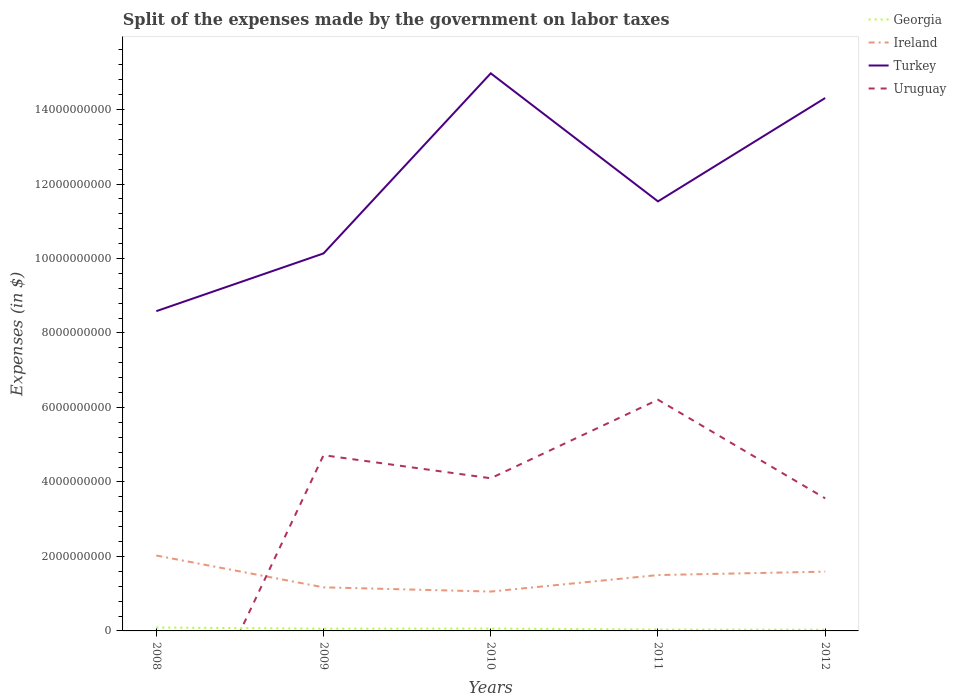How many different coloured lines are there?
Provide a short and direct response. 4. Does the line corresponding to Uruguay intersect with the line corresponding to Ireland?
Offer a terse response. Yes. Across all years, what is the maximum expenses made by the government on labor taxes in Ireland?
Offer a terse response. 1.06e+09. What is the total expenses made by the government on labor taxes in Turkey in the graph?
Make the answer very short. -4.84e+09. What is the difference between the highest and the second highest expenses made by the government on labor taxes in Uruguay?
Ensure brevity in your answer.  6.21e+09. What is the difference between the highest and the lowest expenses made by the government on labor taxes in Ireland?
Give a very brief answer. 3. Is the expenses made by the government on labor taxes in Turkey strictly greater than the expenses made by the government on labor taxes in Ireland over the years?
Provide a succinct answer. No. How many lines are there?
Your response must be concise. 4. What is the difference between two consecutive major ticks on the Y-axis?
Keep it short and to the point. 2.00e+09. Are the values on the major ticks of Y-axis written in scientific E-notation?
Your response must be concise. No. Does the graph contain any zero values?
Your answer should be very brief. Yes. Does the graph contain grids?
Offer a terse response. No. How many legend labels are there?
Keep it short and to the point. 4. How are the legend labels stacked?
Ensure brevity in your answer.  Vertical. What is the title of the graph?
Ensure brevity in your answer.  Split of the expenses made by the government on labor taxes. What is the label or title of the Y-axis?
Provide a short and direct response. Expenses (in $). What is the Expenses (in $) of Georgia in 2008?
Offer a very short reply. 9.18e+07. What is the Expenses (in $) in Ireland in 2008?
Keep it short and to the point. 2.02e+09. What is the Expenses (in $) in Turkey in 2008?
Make the answer very short. 8.59e+09. What is the Expenses (in $) of Uruguay in 2008?
Provide a succinct answer. 0. What is the Expenses (in $) of Georgia in 2009?
Offer a very short reply. 6.00e+07. What is the Expenses (in $) in Ireland in 2009?
Provide a succinct answer. 1.17e+09. What is the Expenses (in $) in Turkey in 2009?
Provide a short and direct response. 1.01e+1. What is the Expenses (in $) in Uruguay in 2009?
Provide a succinct answer. 4.72e+09. What is the Expenses (in $) of Georgia in 2010?
Ensure brevity in your answer.  6.31e+07. What is the Expenses (in $) in Ireland in 2010?
Offer a very short reply. 1.06e+09. What is the Expenses (in $) of Turkey in 2010?
Offer a very short reply. 1.50e+1. What is the Expenses (in $) in Uruguay in 2010?
Provide a succinct answer. 4.10e+09. What is the Expenses (in $) in Georgia in 2011?
Offer a terse response. 3.76e+07. What is the Expenses (in $) in Ireland in 2011?
Ensure brevity in your answer.  1.50e+09. What is the Expenses (in $) of Turkey in 2011?
Your response must be concise. 1.15e+1. What is the Expenses (in $) of Uruguay in 2011?
Your response must be concise. 6.21e+09. What is the Expenses (in $) in Georgia in 2012?
Provide a succinct answer. 3.37e+07. What is the Expenses (in $) in Ireland in 2012?
Offer a terse response. 1.59e+09. What is the Expenses (in $) of Turkey in 2012?
Offer a very short reply. 1.43e+1. What is the Expenses (in $) in Uruguay in 2012?
Your answer should be compact. 3.56e+09. Across all years, what is the maximum Expenses (in $) in Georgia?
Make the answer very short. 9.18e+07. Across all years, what is the maximum Expenses (in $) of Ireland?
Your answer should be compact. 2.02e+09. Across all years, what is the maximum Expenses (in $) of Turkey?
Provide a short and direct response. 1.50e+1. Across all years, what is the maximum Expenses (in $) of Uruguay?
Provide a succinct answer. 6.21e+09. Across all years, what is the minimum Expenses (in $) of Georgia?
Give a very brief answer. 3.37e+07. Across all years, what is the minimum Expenses (in $) of Ireland?
Ensure brevity in your answer.  1.06e+09. Across all years, what is the minimum Expenses (in $) of Turkey?
Provide a succinct answer. 8.59e+09. Across all years, what is the minimum Expenses (in $) of Uruguay?
Offer a terse response. 0. What is the total Expenses (in $) in Georgia in the graph?
Ensure brevity in your answer.  2.86e+08. What is the total Expenses (in $) of Ireland in the graph?
Your answer should be compact. 7.34e+09. What is the total Expenses (in $) in Turkey in the graph?
Give a very brief answer. 5.95e+1. What is the total Expenses (in $) in Uruguay in the graph?
Your answer should be compact. 1.86e+1. What is the difference between the Expenses (in $) of Georgia in 2008 and that in 2009?
Keep it short and to the point. 3.18e+07. What is the difference between the Expenses (in $) of Ireland in 2008 and that in 2009?
Ensure brevity in your answer.  8.54e+08. What is the difference between the Expenses (in $) in Turkey in 2008 and that in 2009?
Your answer should be compact. -1.55e+09. What is the difference between the Expenses (in $) of Georgia in 2008 and that in 2010?
Your response must be concise. 2.87e+07. What is the difference between the Expenses (in $) in Ireland in 2008 and that in 2010?
Keep it short and to the point. 9.68e+08. What is the difference between the Expenses (in $) in Turkey in 2008 and that in 2010?
Ensure brevity in your answer.  -6.39e+09. What is the difference between the Expenses (in $) in Georgia in 2008 and that in 2011?
Provide a succinct answer. 5.42e+07. What is the difference between the Expenses (in $) of Ireland in 2008 and that in 2011?
Keep it short and to the point. 5.25e+08. What is the difference between the Expenses (in $) of Turkey in 2008 and that in 2011?
Keep it short and to the point. -2.95e+09. What is the difference between the Expenses (in $) in Georgia in 2008 and that in 2012?
Keep it short and to the point. 5.81e+07. What is the difference between the Expenses (in $) of Ireland in 2008 and that in 2012?
Make the answer very short. 4.33e+08. What is the difference between the Expenses (in $) of Turkey in 2008 and that in 2012?
Offer a terse response. -5.72e+09. What is the difference between the Expenses (in $) of Georgia in 2009 and that in 2010?
Your answer should be compact. -3.10e+06. What is the difference between the Expenses (in $) in Ireland in 2009 and that in 2010?
Offer a terse response. 1.13e+08. What is the difference between the Expenses (in $) of Turkey in 2009 and that in 2010?
Ensure brevity in your answer.  -4.84e+09. What is the difference between the Expenses (in $) of Uruguay in 2009 and that in 2010?
Ensure brevity in your answer.  6.19e+08. What is the difference between the Expenses (in $) in Georgia in 2009 and that in 2011?
Your answer should be compact. 2.24e+07. What is the difference between the Expenses (in $) in Ireland in 2009 and that in 2011?
Provide a succinct answer. -3.30e+08. What is the difference between the Expenses (in $) of Turkey in 2009 and that in 2011?
Ensure brevity in your answer.  -1.40e+09. What is the difference between the Expenses (in $) of Uruguay in 2009 and that in 2011?
Provide a succinct answer. -1.49e+09. What is the difference between the Expenses (in $) of Georgia in 2009 and that in 2012?
Make the answer very short. 2.63e+07. What is the difference between the Expenses (in $) in Ireland in 2009 and that in 2012?
Provide a succinct answer. -4.21e+08. What is the difference between the Expenses (in $) of Turkey in 2009 and that in 2012?
Keep it short and to the point. -4.17e+09. What is the difference between the Expenses (in $) of Uruguay in 2009 and that in 2012?
Your answer should be compact. 1.16e+09. What is the difference between the Expenses (in $) of Georgia in 2010 and that in 2011?
Keep it short and to the point. 2.55e+07. What is the difference between the Expenses (in $) of Ireland in 2010 and that in 2011?
Your answer should be very brief. -4.43e+08. What is the difference between the Expenses (in $) of Turkey in 2010 and that in 2011?
Provide a succinct answer. 3.44e+09. What is the difference between the Expenses (in $) in Uruguay in 2010 and that in 2011?
Provide a succinct answer. -2.11e+09. What is the difference between the Expenses (in $) of Georgia in 2010 and that in 2012?
Your answer should be very brief. 2.94e+07. What is the difference between the Expenses (in $) of Ireland in 2010 and that in 2012?
Your answer should be very brief. -5.35e+08. What is the difference between the Expenses (in $) in Turkey in 2010 and that in 2012?
Provide a short and direct response. 6.63e+08. What is the difference between the Expenses (in $) of Uruguay in 2010 and that in 2012?
Offer a terse response. 5.40e+08. What is the difference between the Expenses (in $) in Georgia in 2011 and that in 2012?
Give a very brief answer. 3.90e+06. What is the difference between the Expenses (in $) in Ireland in 2011 and that in 2012?
Make the answer very short. -9.14e+07. What is the difference between the Expenses (in $) of Turkey in 2011 and that in 2012?
Offer a very short reply. -2.78e+09. What is the difference between the Expenses (in $) of Uruguay in 2011 and that in 2012?
Provide a succinct answer. 2.65e+09. What is the difference between the Expenses (in $) of Georgia in 2008 and the Expenses (in $) of Ireland in 2009?
Your answer should be very brief. -1.08e+09. What is the difference between the Expenses (in $) in Georgia in 2008 and the Expenses (in $) in Turkey in 2009?
Ensure brevity in your answer.  -1.00e+1. What is the difference between the Expenses (in $) in Georgia in 2008 and the Expenses (in $) in Uruguay in 2009?
Give a very brief answer. -4.63e+09. What is the difference between the Expenses (in $) in Ireland in 2008 and the Expenses (in $) in Turkey in 2009?
Your answer should be compact. -8.11e+09. What is the difference between the Expenses (in $) in Ireland in 2008 and the Expenses (in $) in Uruguay in 2009?
Offer a very short reply. -2.69e+09. What is the difference between the Expenses (in $) of Turkey in 2008 and the Expenses (in $) of Uruguay in 2009?
Your answer should be compact. 3.87e+09. What is the difference between the Expenses (in $) in Georgia in 2008 and the Expenses (in $) in Ireland in 2010?
Keep it short and to the point. -9.65e+08. What is the difference between the Expenses (in $) in Georgia in 2008 and the Expenses (in $) in Turkey in 2010?
Give a very brief answer. -1.49e+1. What is the difference between the Expenses (in $) of Georgia in 2008 and the Expenses (in $) of Uruguay in 2010?
Your answer should be compact. -4.01e+09. What is the difference between the Expenses (in $) in Ireland in 2008 and the Expenses (in $) in Turkey in 2010?
Your response must be concise. -1.29e+1. What is the difference between the Expenses (in $) in Ireland in 2008 and the Expenses (in $) in Uruguay in 2010?
Offer a very short reply. -2.07e+09. What is the difference between the Expenses (in $) of Turkey in 2008 and the Expenses (in $) of Uruguay in 2010?
Provide a short and direct response. 4.49e+09. What is the difference between the Expenses (in $) in Georgia in 2008 and the Expenses (in $) in Ireland in 2011?
Your answer should be compact. -1.41e+09. What is the difference between the Expenses (in $) in Georgia in 2008 and the Expenses (in $) in Turkey in 2011?
Your response must be concise. -1.14e+1. What is the difference between the Expenses (in $) of Georgia in 2008 and the Expenses (in $) of Uruguay in 2011?
Keep it short and to the point. -6.12e+09. What is the difference between the Expenses (in $) in Ireland in 2008 and the Expenses (in $) in Turkey in 2011?
Provide a short and direct response. -9.51e+09. What is the difference between the Expenses (in $) of Ireland in 2008 and the Expenses (in $) of Uruguay in 2011?
Your answer should be very brief. -4.18e+09. What is the difference between the Expenses (in $) of Turkey in 2008 and the Expenses (in $) of Uruguay in 2011?
Provide a succinct answer. 2.38e+09. What is the difference between the Expenses (in $) in Georgia in 2008 and the Expenses (in $) in Ireland in 2012?
Offer a terse response. -1.50e+09. What is the difference between the Expenses (in $) of Georgia in 2008 and the Expenses (in $) of Turkey in 2012?
Offer a terse response. -1.42e+1. What is the difference between the Expenses (in $) in Georgia in 2008 and the Expenses (in $) in Uruguay in 2012?
Give a very brief answer. -3.47e+09. What is the difference between the Expenses (in $) in Ireland in 2008 and the Expenses (in $) in Turkey in 2012?
Provide a short and direct response. -1.23e+1. What is the difference between the Expenses (in $) of Ireland in 2008 and the Expenses (in $) of Uruguay in 2012?
Provide a short and direct response. -1.53e+09. What is the difference between the Expenses (in $) of Turkey in 2008 and the Expenses (in $) of Uruguay in 2012?
Your answer should be compact. 5.03e+09. What is the difference between the Expenses (in $) of Georgia in 2009 and the Expenses (in $) of Ireland in 2010?
Your answer should be compact. -9.97e+08. What is the difference between the Expenses (in $) in Georgia in 2009 and the Expenses (in $) in Turkey in 2010?
Your response must be concise. -1.49e+1. What is the difference between the Expenses (in $) of Georgia in 2009 and the Expenses (in $) of Uruguay in 2010?
Provide a succinct answer. -4.04e+09. What is the difference between the Expenses (in $) of Ireland in 2009 and the Expenses (in $) of Turkey in 2010?
Offer a terse response. -1.38e+1. What is the difference between the Expenses (in $) in Ireland in 2009 and the Expenses (in $) in Uruguay in 2010?
Your response must be concise. -2.93e+09. What is the difference between the Expenses (in $) in Turkey in 2009 and the Expenses (in $) in Uruguay in 2010?
Keep it short and to the point. 6.04e+09. What is the difference between the Expenses (in $) in Georgia in 2009 and the Expenses (in $) in Ireland in 2011?
Provide a short and direct response. -1.44e+09. What is the difference between the Expenses (in $) of Georgia in 2009 and the Expenses (in $) of Turkey in 2011?
Provide a succinct answer. -1.15e+1. What is the difference between the Expenses (in $) in Georgia in 2009 and the Expenses (in $) in Uruguay in 2011?
Provide a short and direct response. -6.15e+09. What is the difference between the Expenses (in $) of Ireland in 2009 and the Expenses (in $) of Turkey in 2011?
Offer a terse response. -1.04e+1. What is the difference between the Expenses (in $) of Ireland in 2009 and the Expenses (in $) of Uruguay in 2011?
Offer a very short reply. -5.04e+09. What is the difference between the Expenses (in $) in Turkey in 2009 and the Expenses (in $) in Uruguay in 2011?
Offer a terse response. 3.93e+09. What is the difference between the Expenses (in $) of Georgia in 2009 and the Expenses (in $) of Ireland in 2012?
Your answer should be very brief. -1.53e+09. What is the difference between the Expenses (in $) in Georgia in 2009 and the Expenses (in $) in Turkey in 2012?
Your answer should be very brief. -1.42e+1. What is the difference between the Expenses (in $) in Georgia in 2009 and the Expenses (in $) in Uruguay in 2012?
Provide a succinct answer. -3.50e+09. What is the difference between the Expenses (in $) in Ireland in 2009 and the Expenses (in $) in Turkey in 2012?
Provide a short and direct response. -1.31e+1. What is the difference between the Expenses (in $) in Ireland in 2009 and the Expenses (in $) in Uruguay in 2012?
Offer a terse response. -2.39e+09. What is the difference between the Expenses (in $) in Turkey in 2009 and the Expenses (in $) in Uruguay in 2012?
Your answer should be compact. 6.58e+09. What is the difference between the Expenses (in $) of Georgia in 2010 and the Expenses (in $) of Ireland in 2011?
Offer a terse response. -1.44e+09. What is the difference between the Expenses (in $) of Georgia in 2010 and the Expenses (in $) of Turkey in 2011?
Your response must be concise. -1.15e+1. What is the difference between the Expenses (in $) in Georgia in 2010 and the Expenses (in $) in Uruguay in 2011?
Your response must be concise. -6.14e+09. What is the difference between the Expenses (in $) in Ireland in 2010 and the Expenses (in $) in Turkey in 2011?
Your response must be concise. -1.05e+1. What is the difference between the Expenses (in $) in Ireland in 2010 and the Expenses (in $) in Uruguay in 2011?
Your answer should be compact. -5.15e+09. What is the difference between the Expenses (in $) in Turkey in 2010 and the Expenses (in $) in Uruguay in 2011?
Your answer should be very brief. 8.76e+09. What is the difference between the Expenses (in $) in Georgia in 2010 and the Expenses (in $) in Ireland in 2012?
Keep it short and to the point. -1.53e+09. What is the difference between the Expenses (in $) of Georgia in 2010 and the Expenses (in $) of Turkey in 2012?
Give a very brief answer. -1.42e+1. What is the difference between the Expenses (in $) of Georgia in 2010 and the Expenses (in $) of Uruguay in 2012?
Offer a very short reply. -3.50e+09. What is the difference between the Expenses (in $) in Ireland in 2010 and the Expenses (in $) in Turkey in 2012?
Offer a terse response. -1.33e+1. What is the difference between the Expenses (in $) of Ireland in 2010 and the Expenses (in $) of Uruguay in 2012?
Give a very brief answer. -2.50e+09. What is the difference between the Expenses (in $) of Turkey in 2010 and the Expenses (in $) of Uruguay in 2012?
Offer a very short reply. 1.14e+1. What is the difference between the Expenses (in $) of Georgia in 2011 and the Expenses (in $) of Ireland in 2012?
Your answer should be very brief. -1.55e+09. What is the difference between the Expenses (in $) of Georgia in 2011 and the Expenses (in $) of Turkey in 2012?
Provide a succinct answer. -1.43e+1. What is the difference between the Expenses (in $) of Georgia in 2011 and the Expenses (in $) of Uruguay in 2012?
Keep it short and to the point. -3.52e+09. What is the difference between the Expenses (in $) in Ireland in 2011 and the Expenses (in $) in Turkey in 2012?
Your answer should be very brief. -1.28e+1. What is the difference between the Expenses (in $) of Ireland in 2011 and the Expenses (in $) of Uruguay in 2012?
Provide a short and direct response. -2.06e+09. What is the difference between the Expenses (in $) of Turkey in 2011 and the Expenses (in $) of Uruguay in 2012?
Ensure brevity in your answer.  7.97e+09. What is the average Expenses (in $) of Georgia per year?
Your answer should be compact. 5.72e+07. What is the average Expenses (in $) of Ireland per year?
Make the answer very short. 1.47e+09. What is the average Expenses (in $) in Turkey per year?
Provide a short and direct response. 1.19e+1. What is the average Expenses (in $) in Uruguay per year?
Your answer should be very brief. 3.72e+09. In the year 2008, what is the difference between the Expenses (in $) of Georgia and Expenses (in $) of Ireland?
Your answer should be compact. -1.93e+09. In the year 2008, what is the difference between the Expenses (in $) of Georgia and Expenses (in $) of Turkey?
Provide a short and direct response. -8.49e+09. In the year 2008, what is the difference between the Expenses (in $) of Ireland and Expenses (in $) of Turkey?
Your answer should be compact. -6.56e+09. In the year 2009, what is the difference between the Expenses (in $) of Georgia and Expenses (in $) of Ireland?
Offer a very short reply. -1.11e+09. In the year 2009, what is the difference between the Expenses (in $) of Georgia and Expenses (in $) of Turkey?
Your response must be concise. -1.01e+1. In the year 2009, what is the difference between the Expenses (in $) of Georgia and Expenses (in $) of Uruguay?
Offer a terse response. -4.66e+09. In the year 2009, what is the difference between the Expenses (in $) in Ireland and Expenses (in $) in Turkey?
Offer a terse response. -8.97e+09. In the year 2009, what is the difference between the Expenses (in $) of Ireland and Expenses (in $) of Uruguay?
Ensure brevity in your answer.  -3.55e+09. In the year 2009, what is the difference between the Expenses (in $) of Turkey and Expenses (in $) of Uruguay?
Ensure brevity in your answer.  5.42e+09. In the year 2010, what is the difference between the Expenses (in $) of Georgia and Expenses (in $) of Ireland?
Your answer should be compact. -9.94e+08. In the year 2010, what is the difference between the Expenses (in $) of Georgia and Expenses (in $) of Turkey?
Provide a short and direct response. -1.49e+1. In the year 2010, what is the difference between the Expenses (in $) of Georgia and Expenses (in $) of Uruguay?
Offer a terse response. -4.04e+09. In the year 2010, what is the difference between the Expenses (in $) of Ireland and Expenses (in $) of Turkey?
Ensure brevity in your answer.  -1.39e+1. In the year 2010, what is the difference between the Expenses (in $) in Ireland and Expenses (in $) in Uruguay?
Give a very brief answer. -3.04e+09. In the year 2010, what is the difference between the Expenses (in $) in Turkey and Expenses (in $) in Uruguay?
Ensure brevity in your answer.  1.09e+1. In the year 2011, what is the difference between the Expenses (in $) of Georgia and Expenses (in $) of Ireland?
Offer a terse response. -1.46e+09. In the year 2011, what is the difference between the Expenses (in $) of Georgia and Expenses (in $) of Turkey?
Ensure brevity in your answer.  -1.15e+1. In the year 2011, what is the difference between the Expenses (in $) in Georgia and Expenses (in $) in Uruguay?
Your response must be concise. -6.17e+09. In the year 2011, what is the difference between the Expenses (in $) in Ireland and Expenses (in $) in Turkey?
Provide a succinct answer. -1.00e+1. In the year 2011, what is the difference between the Expenses (in $) in Ireland and Expenses (in $) in Uruguay?
Provide a short and direct response. -4.71e+09. In the year 2011, what is the difference between the Expenses (in $) in Turkey and Expenses (in $) in Uruguay?
Keep it short and to the point. 5.33e+09. In the year 2012, what is the difference between the Expenses (in $) in Georgia and Expenses (in $) in Ireland?
Ensure brevity in your answer.  -1.56e+09. In the year 2012, what is the difference between the Expenses (in $) of Georgia and Expenses (in $) of Turkey?
Give a very brief answer. -1.43e+1. In the year 2012, what is the difference between the Expenses (in $) in Georgia and Expenses (in $) in Uruguay?
Make the answer very short. -3.53e+09. In the year 2012, what is the difference between the Expenses (in $) of Ireland and Expenses (in $) of Turkey?
Offer a very short reply. -1.27e+1. In the year 2012, what is the difference between the Expenses (in $) in Ireland and Expenses (in $) in Uruguay?
Provide a succinct answer. -1.97e+09. In the year 2012, what is the difference between the Expenses (in $) in Turkey and Expenses (in $) in Uruguay?
Give a very brief answer. 1.07e+1. What is the ratio of the Expenses (in $) in Georgia in 2008 to that in 2009?
Provide a short and direct response. 1.53. What is the ratio of the Expenses (in $) in Ireland in 2008 to that in 2009?
Your answer should be compact. 1.73. What is the ratio of the Expenses (in $) in Turkey in 2008 to that in 2009?
Ensure brevity in your answer.  0.85. What is the ratio of the Expenses (in $) in Georgia in 2008 to that in 2010?
Keep it short and to the point. 1.45. What is the ratio of the Expenses (in $) in Ireland in 2008 to that in 2010?
Provide a succinct answer. 1.92. What is the ratio of the Expenses (in $) in Turkey in 2008 to that in 2010?
Ensure brevity in your answer.  0.57. What is the ratio of the Expenses (in $) in Georgia in 2008 to that in 2011?
Your response must be concise. 2.44. What is the ratio of the Expenses (in $) of Ireland in 2008 to that in 2011?
Make the answer very short. 1.35. What is the ratio of the Expenses (in $) in Turkey in 2008 to that in 2011?
Your answer should be very brief. 0.74. What is the ratio of the Expenses (in $) in Georgia in 2008 to that in 2012?
Your response must be concise. 2.72. What is the ratio of the Expenses (in $) in Ireland in 2008 to that in 2012?
Offer a very short reply. 1.27. What is the ratio of the Expenses (in $) in Turkey in 2008 to that in 2012?
Your answer should be very brief. 0.6. What is the ratio of the Expenses (in $) in Georgia in 2009 to that in 2010?
Offer a very short reply. 0.95. What is the ratio of the Expenses (in $) in Ireland in 2009 to that in 2010?
Offer a very short reply. 1.11. What is the ratio of the Expenses (in $) in Turkey in 2009 to that in 2010?
Give a very brief answer. 0.68. What is the ratio of the Expenses (in $) of Uruguay in 2009 to that in 2010?
Provide a short and direct response. 1.15. What is the ratio of the Expenses (in $) of Georgia in 2009 to that in 2011?
Make the answer very short. 1.6. What is the ratio of the Expenses (in $) in Ireland in 2009 to that in 2011?
Your response must be concise. 0.78. What is the ratio of the Expenses (in $) of Turkey in 2009 to that in 2011?
Offer a terse response. 0.88. What is the ratio of the Expenses (in $) of Uruguay in 2009 to that in 2011?
Offer a terse response. 0.76. What is the ratio of the Expenses (in $) in Georgia in 2009 to that in 2012?
Ensure brevity in your answer.  1.78. What is the ratio of the Expenses (in $) of Ireland in 2009 to that in 2012?
Give a very brief answer. 0.74. What is the ratio of the Expenses (in $) in Turkey in 2009 to that in 2012?
Your response must be concise. 0.71. What is the ratio of the Expenses (in $) of Uruguay in 2009 to that in 2012?
Provide a short and direct response. 1.33. What is the ratio of the Expenses (in $) in Georgia in 2010 to that in 2011?
Your answer should be compact. 1.68. What is the ratio of the Expenses (in $) in Ireland in 2010 to that in 2011?
Your response must be concise. 0.7. What is the ratio of the Expenses (in $) in Turkey in 2010 to that in 2011?
Your response must be concise. 1.3. What is the ratio of the Expenses (in $) in Uruguay in 2010 to that in 2011?
Ensure brevity in your answer.  0.66. What is the ratio of the Expenses (in $) in Georgia in 2010 to that in 2012?
Keep it short and to the point. 1.87. What is the ratio of the Expenses (in $) of Ireland in 2010 to that in 2012?
Your response must be concise. 0.66. What is the ratio of the Expenses (in $) in Turkey in 2010 to that in 2012?
Give a very brief answer. 1.05. What is the ratio of the Expenses (in $) in Uruguay in 2010 to that in 2012?
Your response must be concise. 1.15. What is the ratio of the Expenses (in $) of Georgia in 2011 to that in 2012?
Your response must be concise. 1.12. What is the ratio of the Expenses (in $) of Ireland in 2011 to that in 2012?
Ensure brevity in your answer.  0.94. What is the ratio of the Expenses (in $) of Turkey in 2011 to that in 2012?
Provide a short and direct response. 0.81. What is the ratio of the Expenses (in $) of Uruguay in 2011 to that in 2012?
Offer a very short reply. 1.74. What is the difference between the highest and the second highest Expenses (in $) in Georgia?
Offer a terse response. 2.87e+07. What is the difference between the highest and the second highest Expenses (in $) of Ireland?
Provide a short and direct response. 4.33e+08. What is the difference between the highest and the second highest Expenses (in $) of Turkey?
Your answer should be compact. 6.63e+08. What is the difference between the highest and the second highest Expenses (in $) of Uruguay?
Ensure brevity in your answer.  1.49e+09. What is the difference between the highest and the lowest Expenses (in $) of Georgia?
Your answer should be compact. 5.81e+07. What is the difference between the highest and the lowest Expenses (in $) of Ireland?
Provide a short and direct response. 9.68e+08. What is the difference between the highest and the lowest Expenses (in $) in Turkey?
Make the answer very short. 6.39e+09. What is the difference between the highest and the lowest Expenses (in $) in Uruguay?
Make the answer very short. 6.21e+09. 